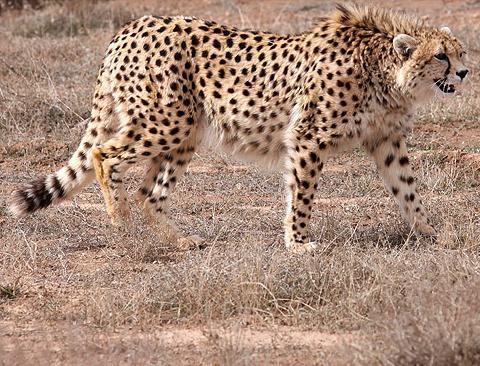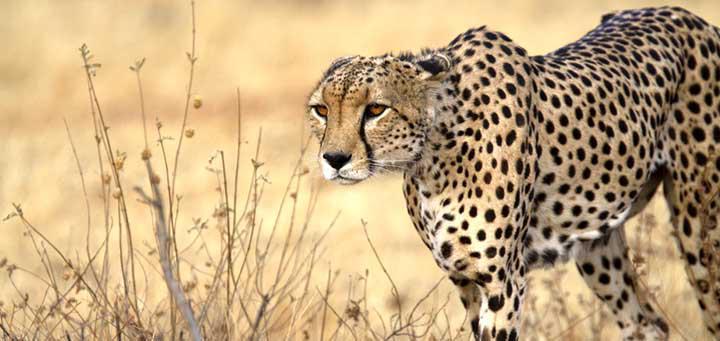The first image is the image on the left, the second image is the image on the right. Evaluate the accuracy of this statement regarding the images: "In the image on the right, there are no cheetahs - instead we have leopards, with broader faces, and larger spots, without the black tear duct path the cheetahs have.". Is it true? Answer yes or no. No. The first image is the image on the left, the second image is the image on the right. Considering the images on both sides, is "the right image has three cheetas" valid? Answer yes or no. No. 